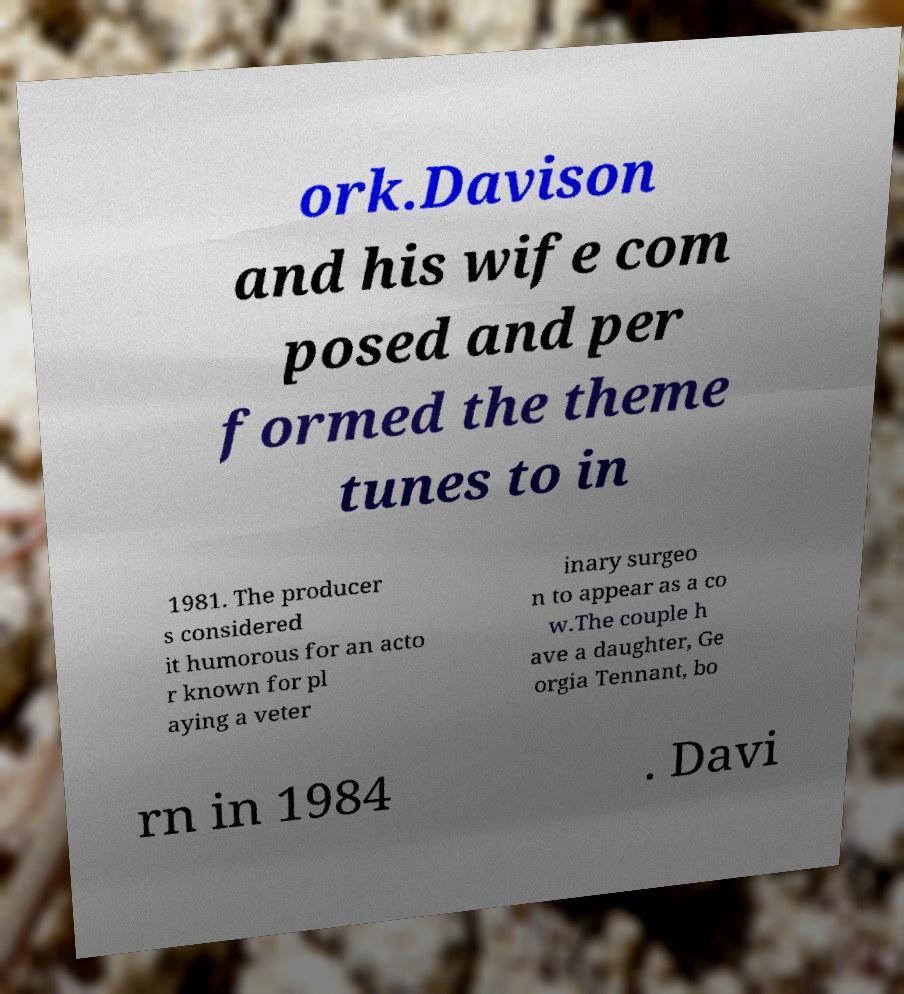For documentation purposes, I need the text within this image transcribed. Could you provide that? ork.Davison and his wife com posed and per formed the theme tunes to in 1981. The producer s considered it humorous for an acto r known for pl aying a veter inary surgeo n to appear as a co w.The couple h ave a daughter, Ge orgia Tennant, bo rn in 1984 . Davi 